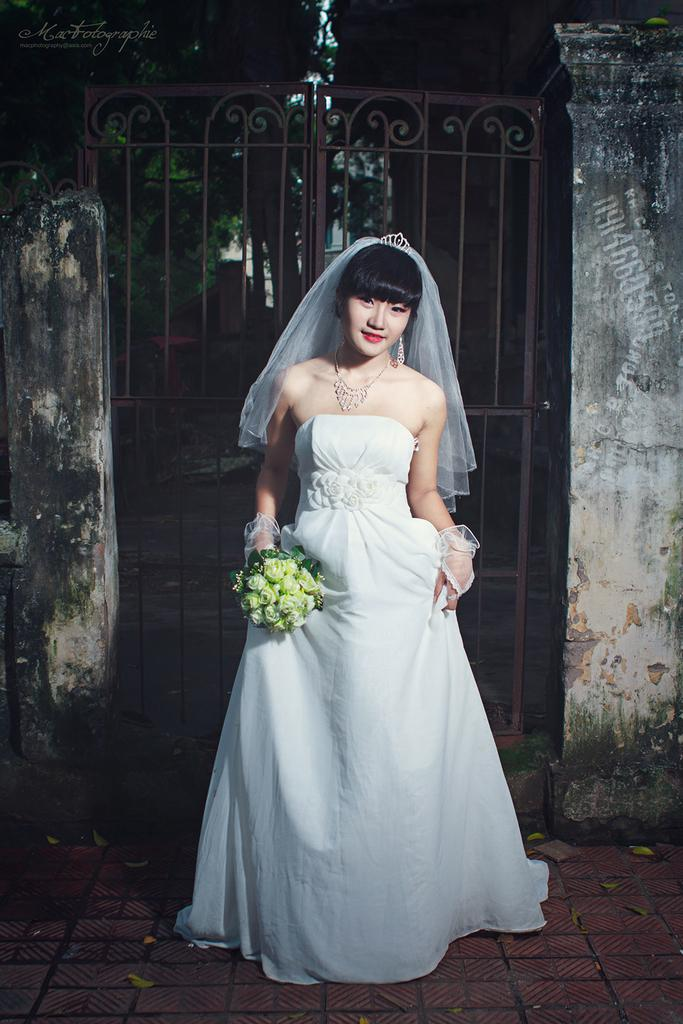Who is present in the image? There is a woman in the image. What is the woman wearing? The woman is wearing a white dress. What is the woman holding in the image? The woman is holding a flower bouquet. What can be seen in the background of the image? There is a gate, trees, and walls in the background of the image. Is there any text or logo on the image? Yes, there is a watermark on the image. What type of meat is being prepared in the image? There is no meat present in the image; it features a woman holding a flower bouquet. What is the title of the image? The image does not have a title, as it is a photograph and not a piece of artwork with a title. 